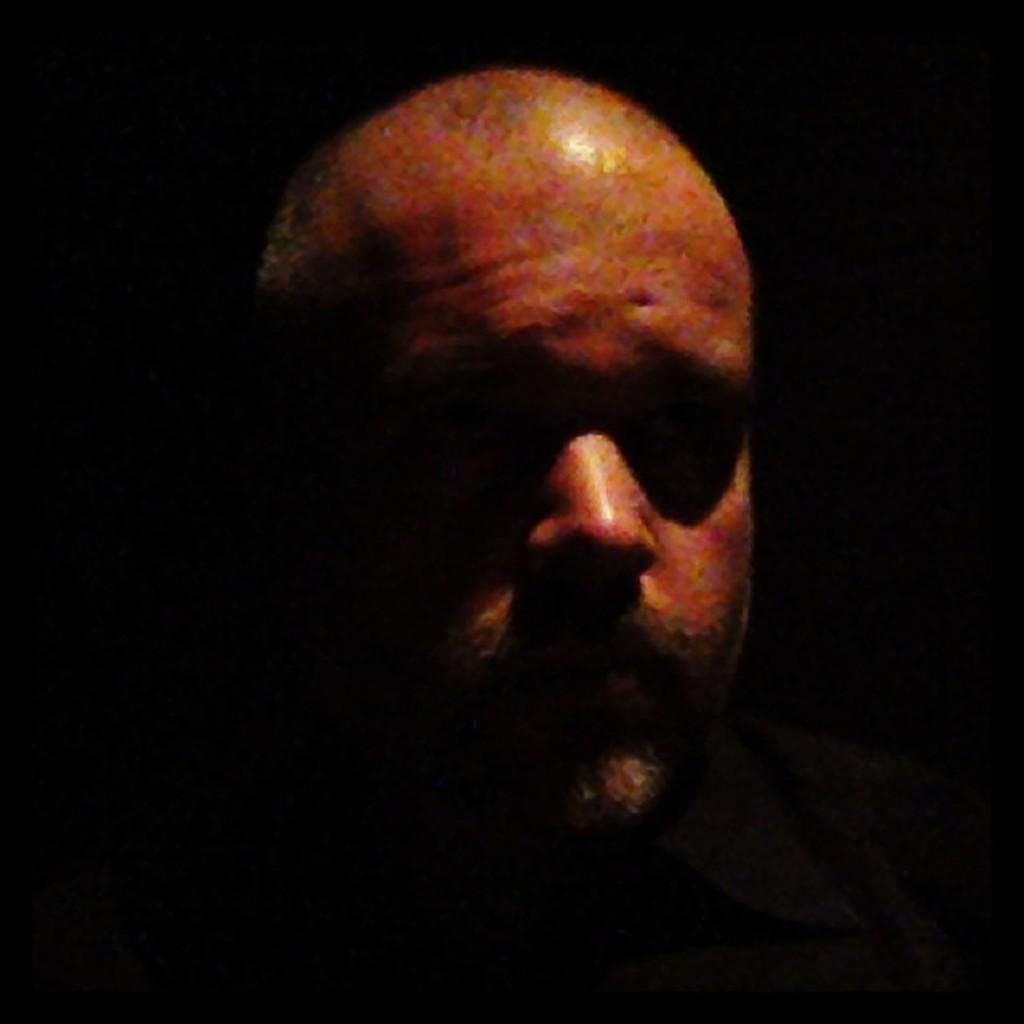Who is present in the image? There is a man in the image. Can you describe the lighting conditions in the image? The image is dark. How many toes can be seen on the man's foot in the image? There is no visible foot or toes in the image, as it is too dark to see such details. 